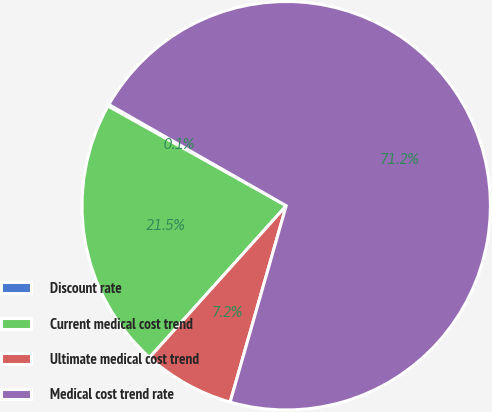Convert chart. <chart><loc_0><loc_0><loc_500><loc_500><pie_chart><fcel>Discount rate<fcel>Current medical cost trend<fcel>Ultimate medical cost trend<fcel>Medical cost trend rate<nl><fcel>0.14%<fcel>21.45%<fcel>7.24%<fcel>71.17%<nl></chart> 